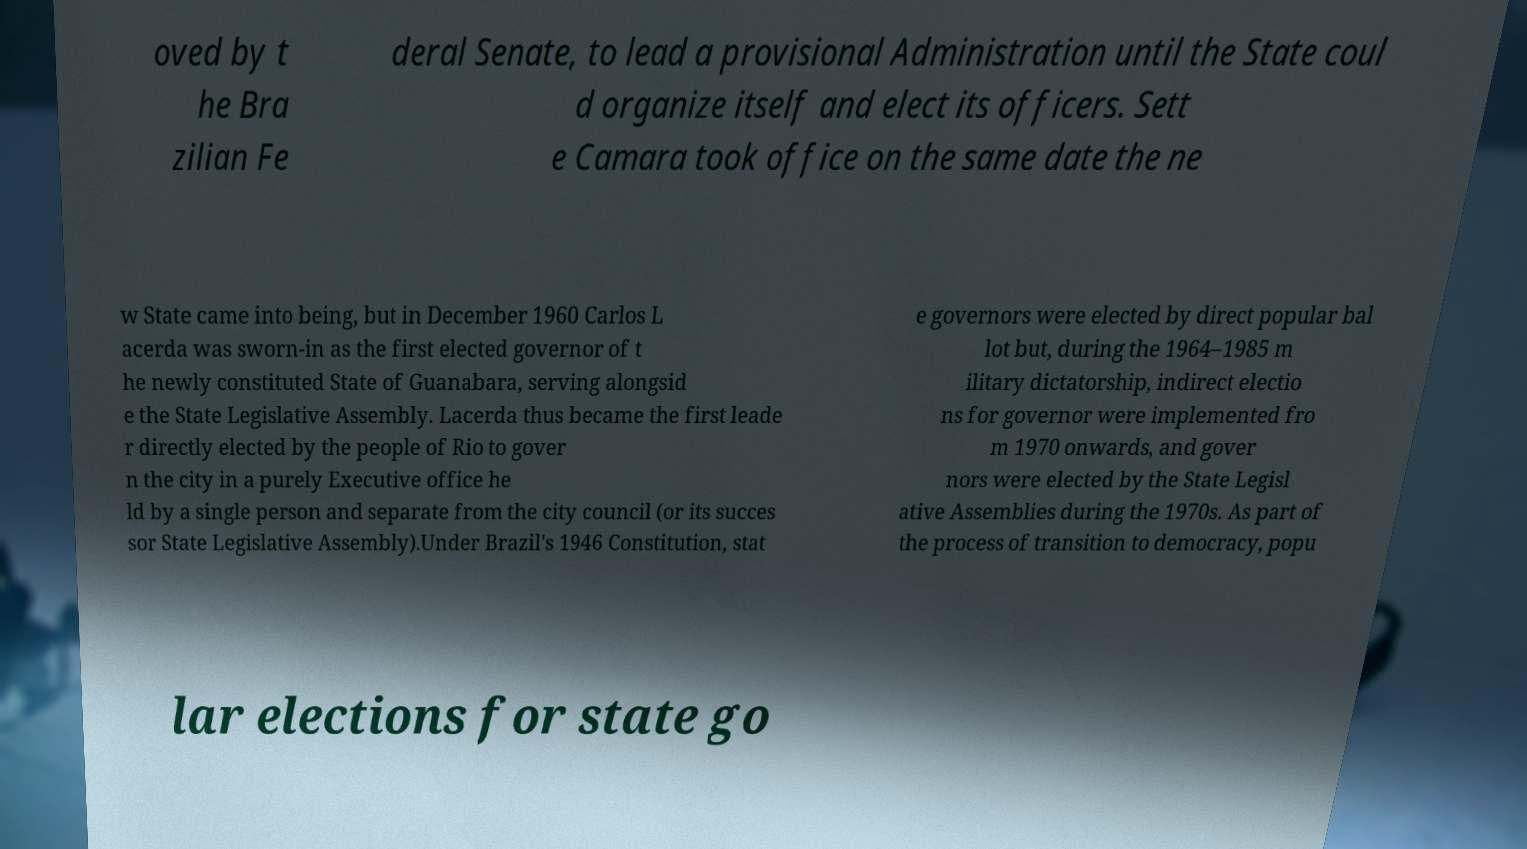What messages or text are displayed in this image? I need them in a readable, typed format. oved by t he Bra zilian Fe deral Senate, to lead a provisional Administration until the State coul d organize itself and elect its officers. Sett e Camara took office on the same date the ne w State came into being, but in December 1960 Carlos L acerda was sworn-in as the first elected governor of t he newly constituted State of Guanabara, serving alongsid e the State Legislative Assembly. Lacerda thus became the first leade r directly elected by the people of Rio to gover n the city in a purely Executive office he ld by a single person and separate from the city council (or its succes sor State Legislative Assembly).Under Brazil's 1946 Constitution, stat e governors were elected by direct popular bal lot but, during the 1964–1985 m ilitary dictatorship, indirect electio ns for governor were implemented fro m 1970 onwards, and gover nors were elected by the State Legisl ative Assemblies during the 1970s. As part of the process of transition to democracy, popu lar elections for state go 